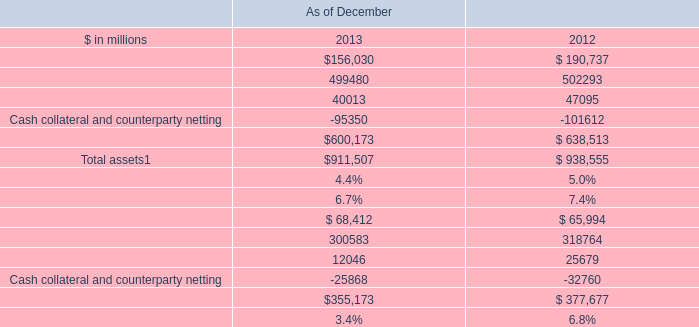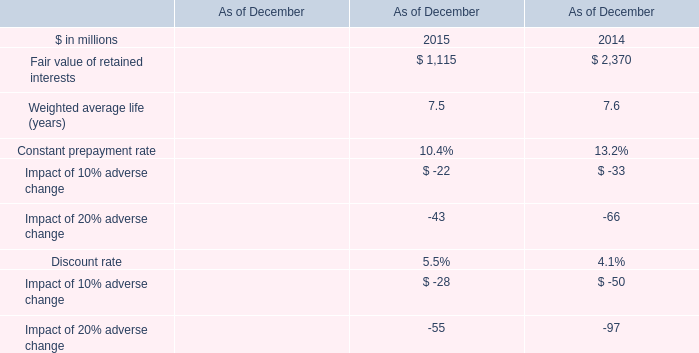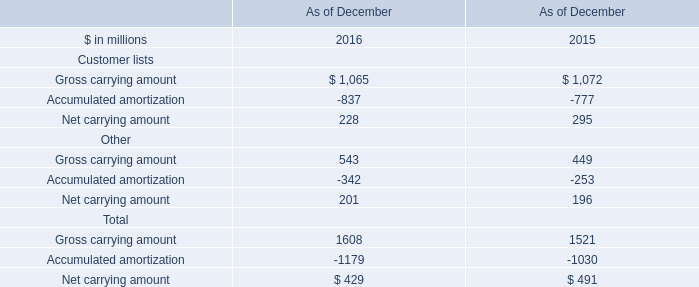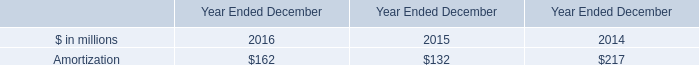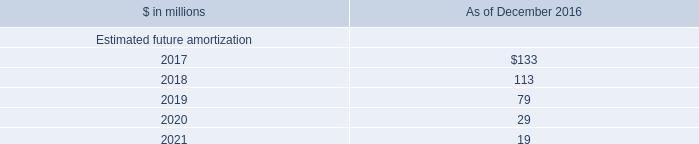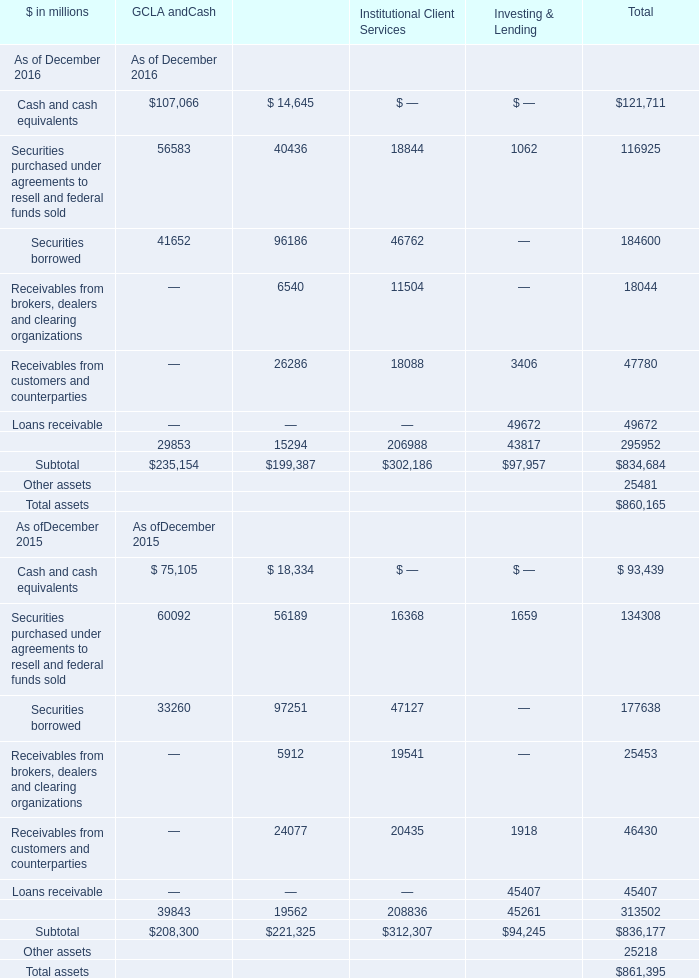What is the ratio of Securities purchased under agreements to resell and federal funds sold of Investing Lending in Table 5 to the Amortization in Table 3 in 2016? 
Computations: (1062 / 162)
Answer: 6.55556. 